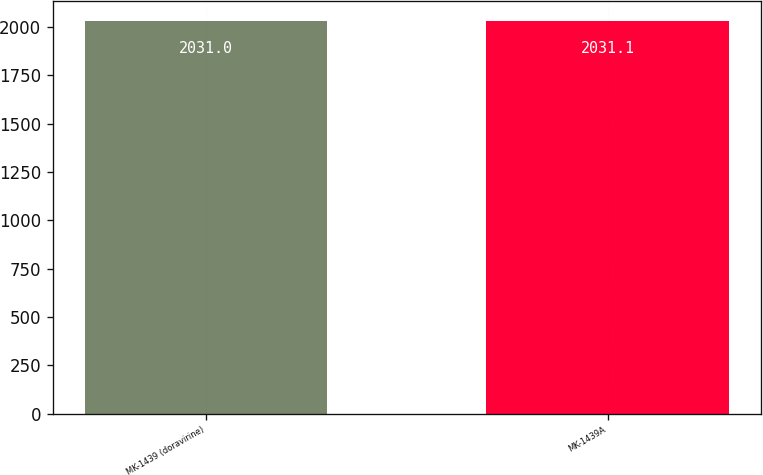Convert chart. <chart><loc_0><loc_0><loc_500><loc_500><bar_chart><fcel>MK-1439 (doravirine)<fcel>MK-1439A<nl><fcel>2031<fcel>2031.1<nl></chart> 